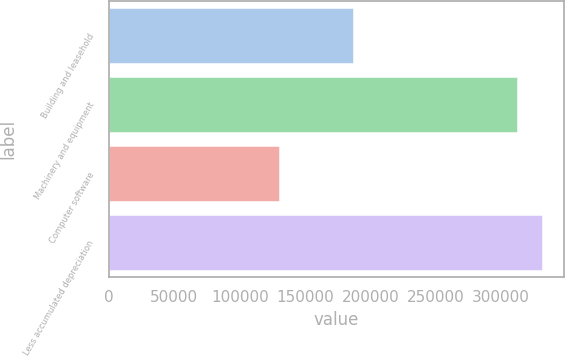Convert chart to OTSL. <chart><loc_0><loc_0><loc_500><loc_500><bar_chart><fcel>Building and leasehold<fcel>Machinery and equipment<fcel>Computer software<fcel>Less accumulated depreciation<nl><fcel>186974<fcel>312501<fcel>129697<fcel>331366<nl></chart> 